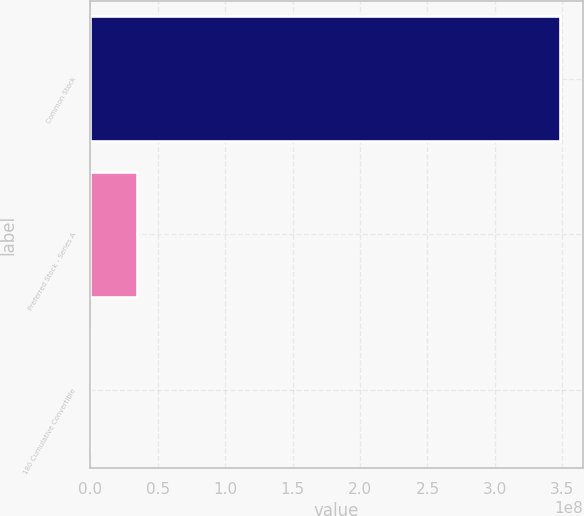<chart> <loc_0><loc_0><loc_500><loc_500><bar_chart><fcel>Common Stock<fcel>Preferred Stock - Series A<fcel>180 Cumulative Convertible<nl><fcel>3.4796e+08<fcel>3.48042e+07<fcel>9096<nl></chart> 